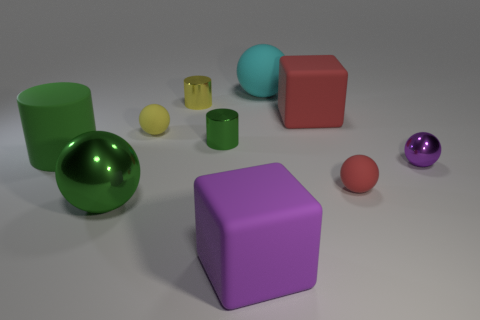Subtract all green spheres. How many spheres are left? 4 Subtract all matte cylinders. How many cylinders are left? 2 Subtract all cylinders. How many objects are left? 7 Subtract 3 balls. How many balls are left? 2 Add 1 large green rubber objects. How many large green rubber objects are left? 2 Add 6 tiny gray metallic things. How many tiny gray metallic things exist? 6 Subtract 1 purple blocks. How many objects are left? 9 Subtract all cyan cubes. Subtract all purple balls. How many cubes are left? 2 Subtract all cyan cubes. How many yellow spheres are left? 1 Subtract all purple blocks. Subtract all green cylinders. How many objects are left? 7 